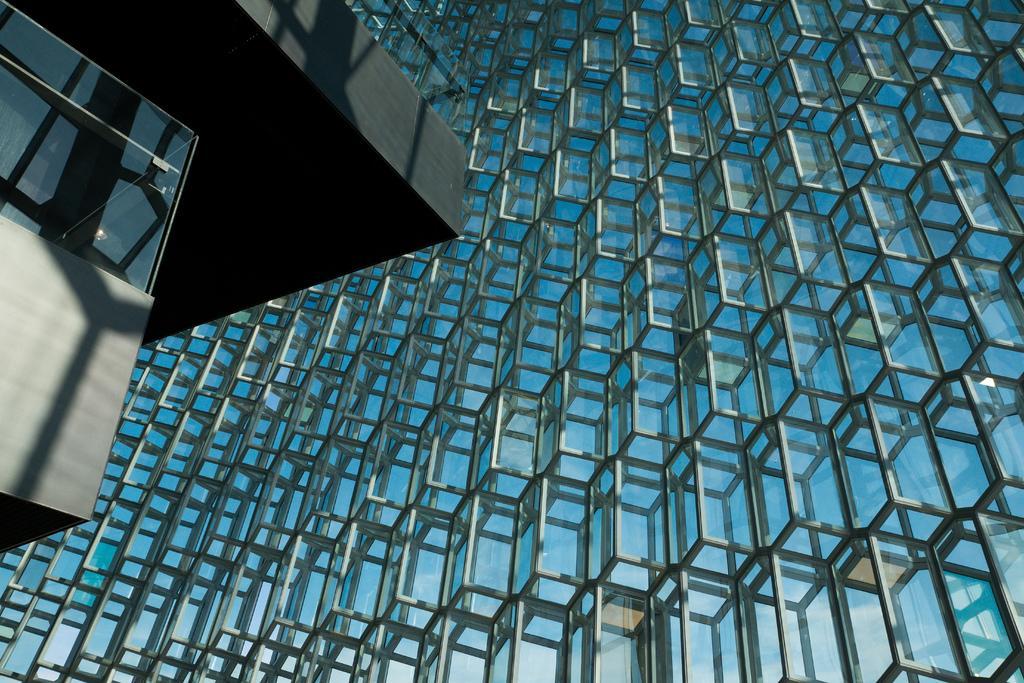Describe this image in one or two sentences. This is the picture of a building. In this image there is a reflection of sky on the building. On the left side of the image there is a light bulb behind the window. 